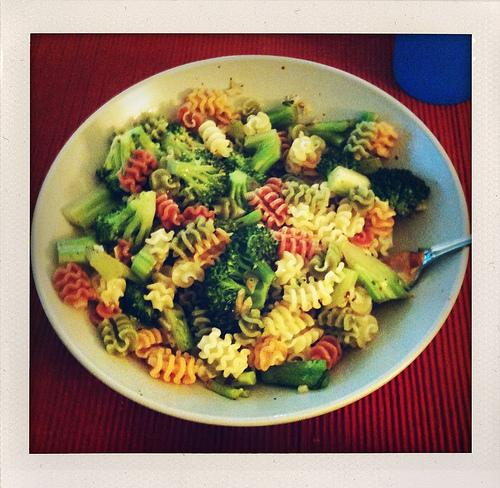What is in the bowl?

Choices:
A) beef stew
B) pasta
C) apples
D) pizza pasta 